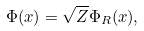<formula> <loc_0><loc_0><loc_500><loc_500>\Phi ( x ) = \sqrt { Z } \Phi _ { R } ( x ) ,</formula> 